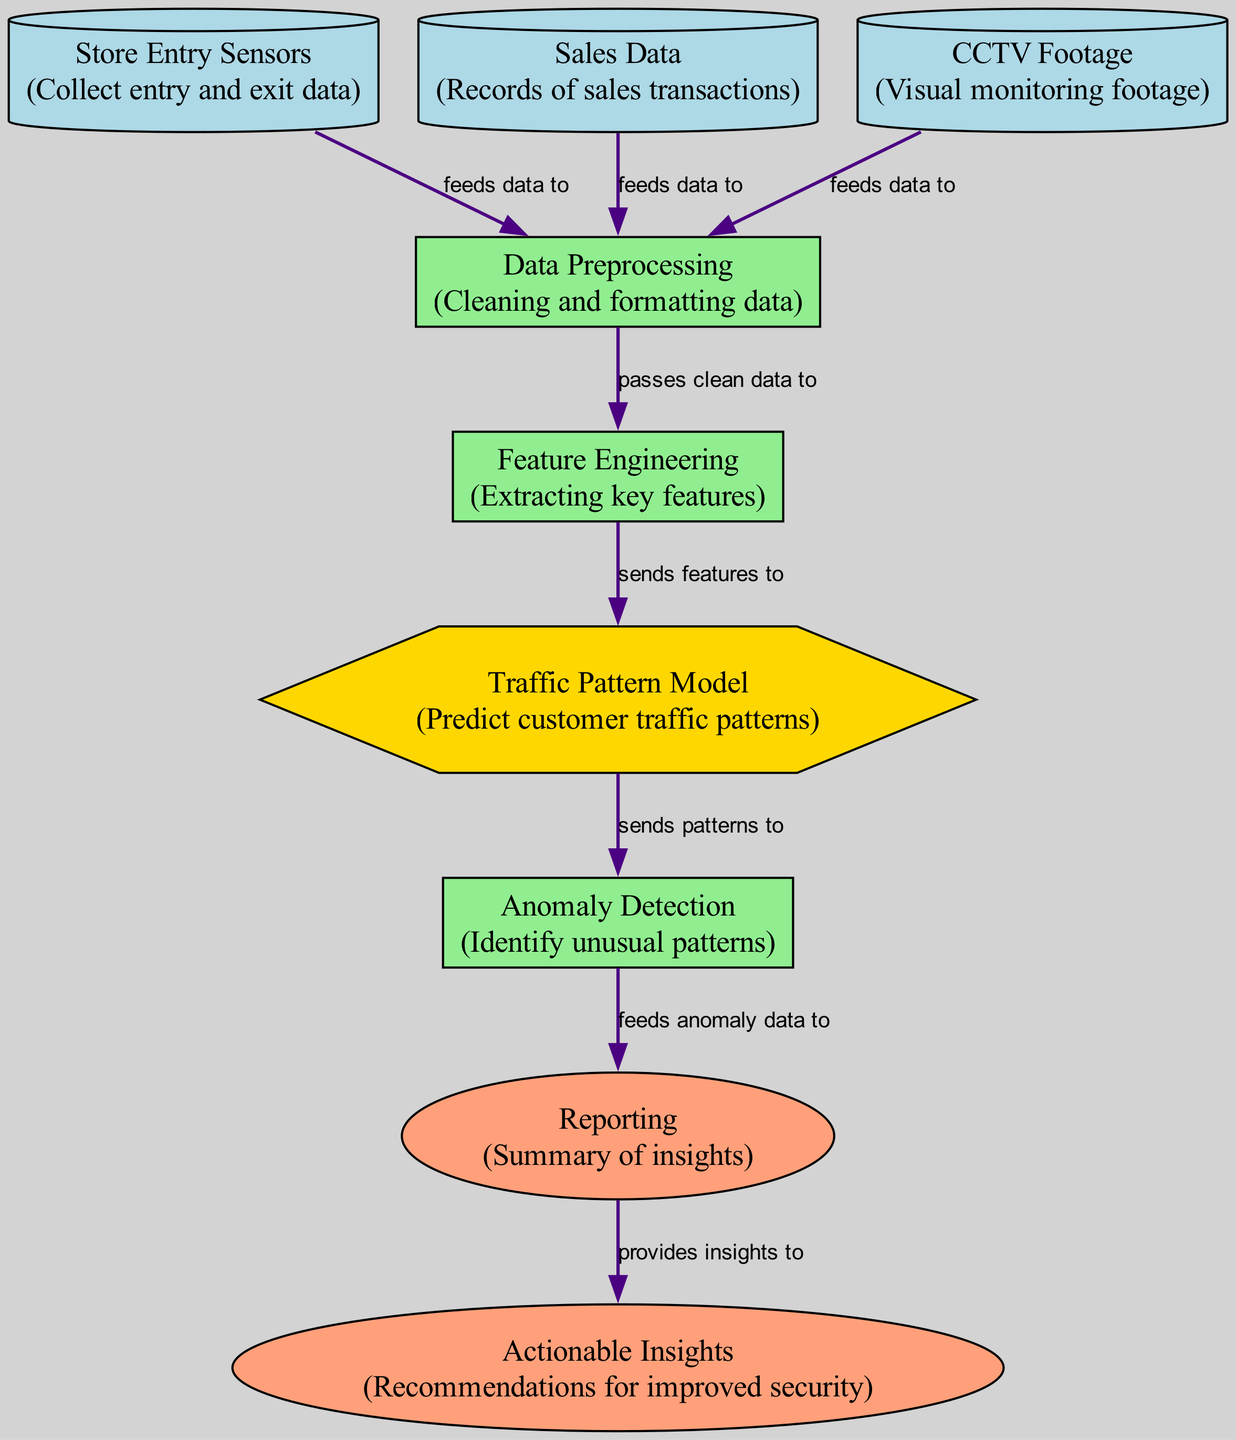What types of nodes are present in the diagram? The diagram contains three types of nodes: data source, process, and output. By identifying each node's type as described in the data provided, I can classify them accordingly.
Answer: data source, process, output How many data source nodes are there? In total, there are three data source nodes: Store Entry Sensors, Sales Data, and CCTV Footage. Counting these nodes gives the total.
Answer: three What is the output of the Anomaly Detection process? The Anomaly Detection process feeds anomaly data to the Reporting node. By tracing the connection from Anomaly Detection to Reporting, I determine its output.
Answer: anomaly data Which node receives data from the Store Entry Sensors? The Store Entry Sensors provide data to the Data Preprocessing node. By examining the directed edge from Store Entry Sensors to Data Preprocessing, it is clear which node receives the input.
Answer: Data Preprocessing What do the Reporting and Actionable Insights nodes represent? Both nodes represent different outputs of the analysis process. Reporting summarizes insights, while Actionable Insights provides recommendations for improved security. Assessing the descriptions of these nodes leads to this classification.
Answer: outputs What is the purpose of the Feature Engineering process? The Feature Engineering process extracts key features from the cleaned data passed to it by the Data Preprocessing node. By understanding its role in transforming data, the purpose is established.
Answer: extracting key features How does customer traffic pattern prediction relate to anomaly detection? The Traffic Pattern Model sends patterns to Anomaly Detection, indicating that the predicted patterns are utilized to identify any unusual activity. Tracing the flow from the Traffic Pattern Model to Anomaly Detection reveals this connection.
Answer: sends patterns to What is the last stage of the process flow before reaching Actionable Insights? The last process before reaching Actionable Insights is Reporting, which provides insights to Actionable Insights. Observing the final edges in the flow of the diagram clarifies this step.
Answer: Reporting 